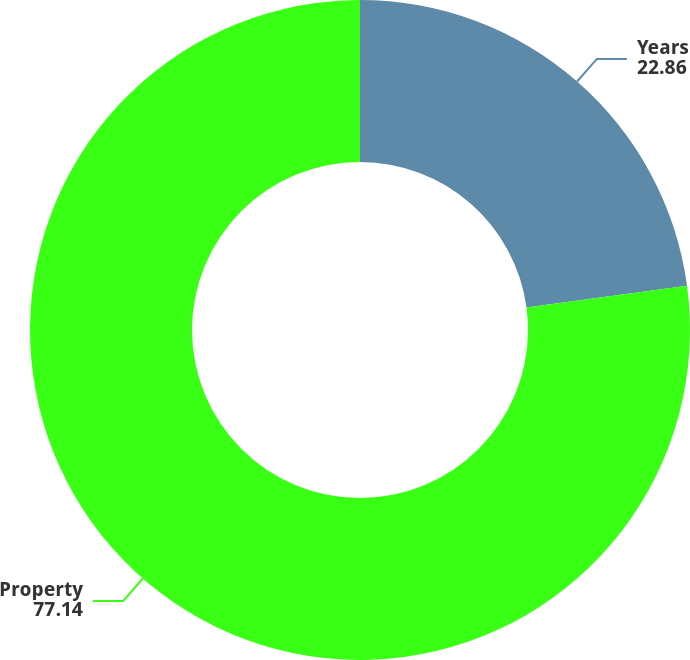Convert chart to OTSL. <chart><loc_0><loc_0><loc_500><loc_500><pie_chart><fcel>Years<fcel>Property<nl><fcel>22.86%<fcel>77.14%<nl></chart> 